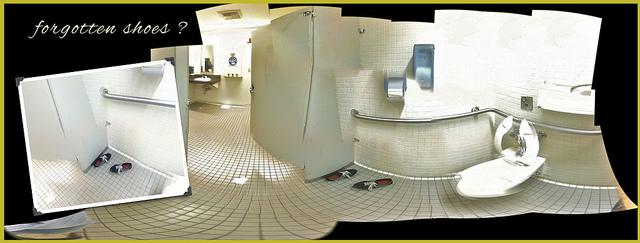What room is this called?
Concise answer only. Bathroom. What kind of room are the shoes located in?
Quick response, please. Bathroom. How many shoes are in the picture?
Keep it brief. 2. 